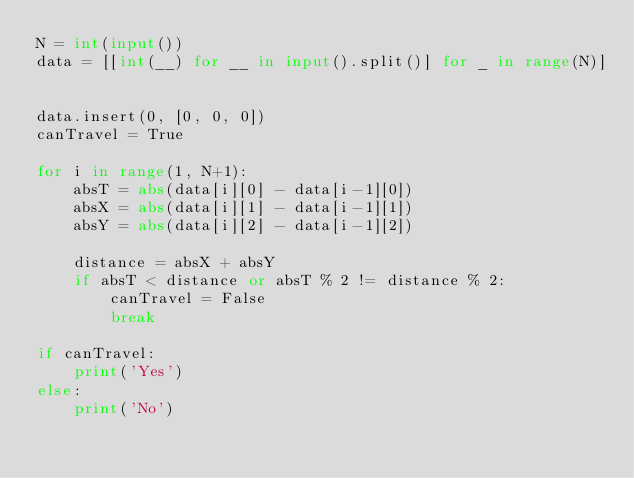Convert code to text. <code><loc_0><loc_0><loc_500><loc_500><_Python_>N = int(input())
data = [[int(__) for __ in input().split()] for _ in range(N)]


data.insert(0, [0, 0, 0])
canTravel = True

for i in range(1, N+1):
    absT = abs(data[i][0] - data[i-1][0])
    absX = abs(data[i][1] - data[i-1][1])
    absY = abs(data[i][2] - data[i-1][2])

    distance = absX + absY
    if absT < distance or absT % 2 != distance % 2:
        canTravel = False
        break

if canTravel:
    print('Yes')
else:
    print('No')
</code> 